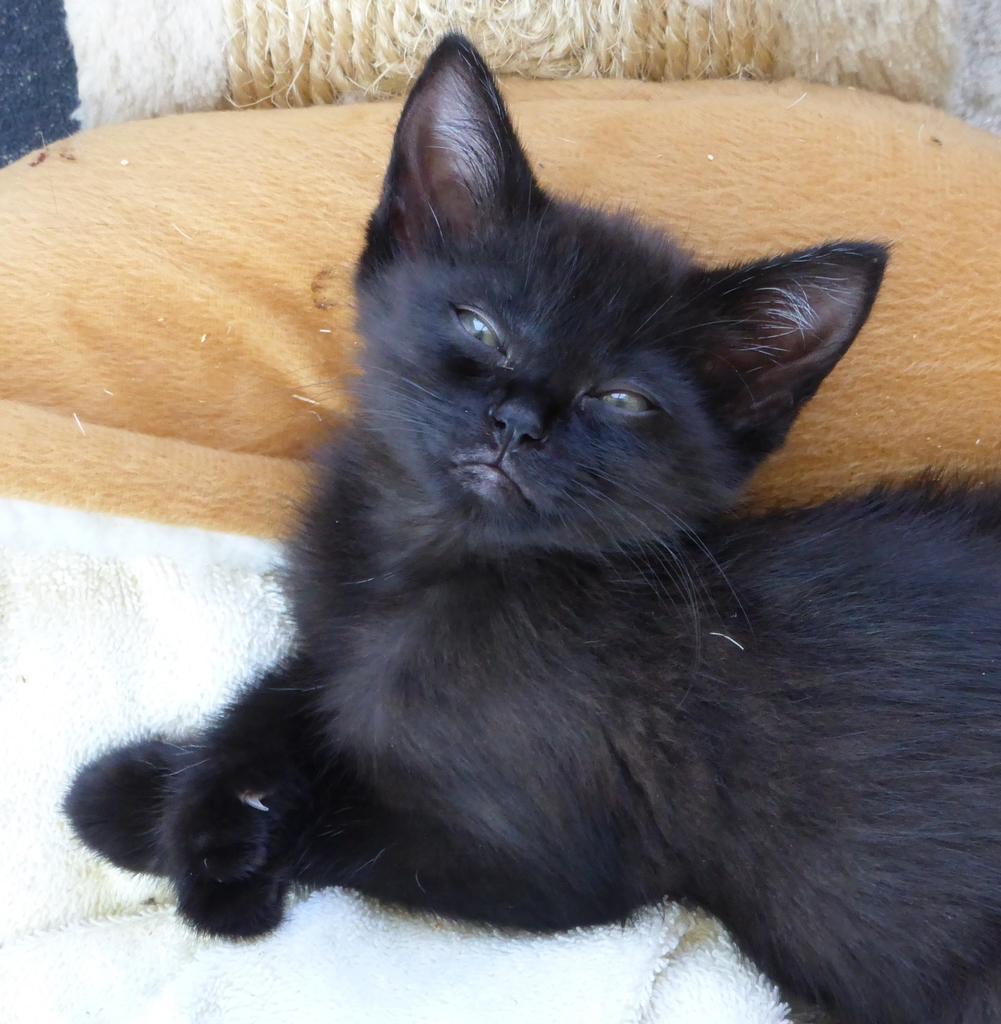In one or two sentences, can you explain what this image depicts? In this image I can see a black color cat is sitting on a white color cloth. Beside this I can see a pillow. 